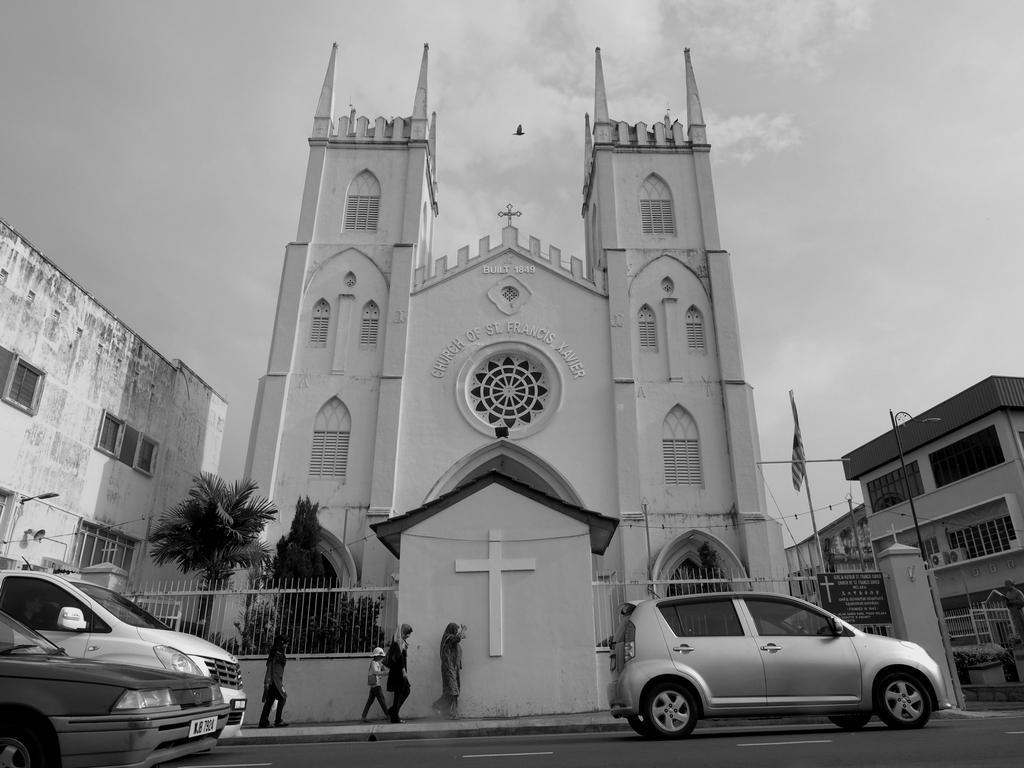Could you give a brief overview of what you see in this image? This is the black and white image where we can see cars moving on the road, a few people walking on the sidewalk and we can see fence. In the background, we can see the fence, the Church, buildings, fence, wires, sky with clouds and a bird flying in the air in the background. 